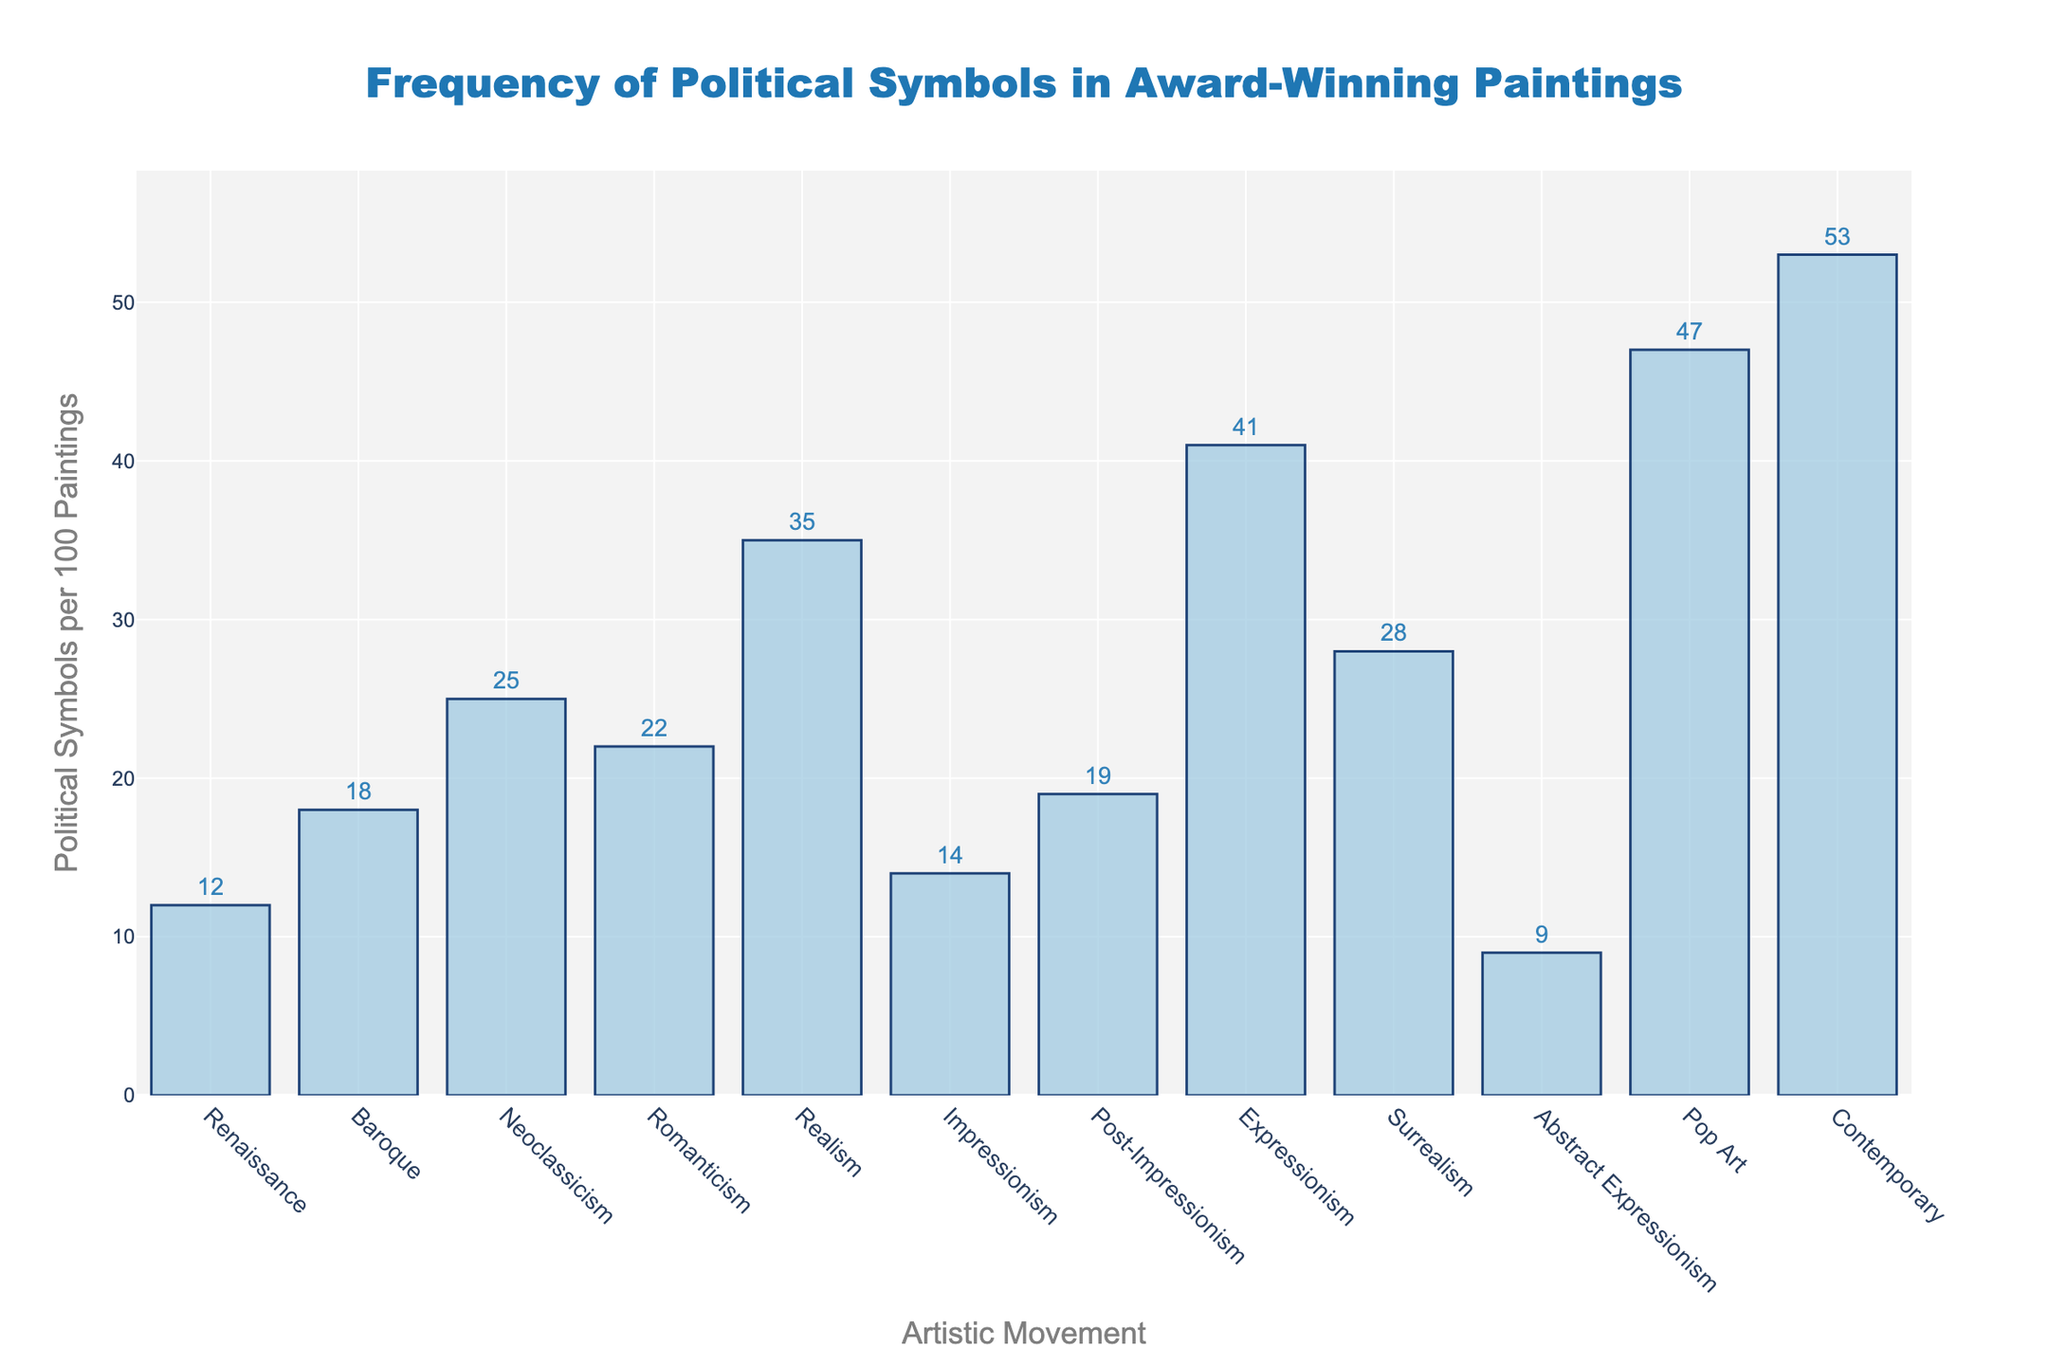What's the artistic movement with the highest frequency of political symbols? The tallest bar in the chart represents the "Contemporary" movement, indicating the highest frequency of political symbols per 100 paintings.
Answer: Contemporary Which artistic movement has a lower frequency of political symbols: Renaissance or Abstract Expressionism? By comparing the heights of the bars, "Abstract Expressionism" has fewer political symbols per 100 paintings (9) than the "Renaissance" (12).
Answer: Abstract Expressionism What is the difference in the frequency of political symbols between Surrealism and Realism? The bar for "Surrealism" shows 28 symbols, and "Realism" shows 35 symbols. The difference is 35 - 28 = 7 symbols.
Answer: 7 Which artistic movements have a frequency of political symbols greater than 20 but less than 30? Bars between 20 and 30 symbols represent "Romanticism" (22), "Post-Impressionism" (19), and "Surrealism" (28). After considering the given ranges, the applicable movements are "Romanticism" and "Surrealism".
Answer: Romanticism, Surrealism How many artistic movements have a frequency of political symbols less than 15? By evaluating the heights, the bars shorter than 15 symbols per 100 paintings are "Renaissance" (12), "Impressionism" (14), and "Abstract Expressionism" (9). Counting these, we get three movements.
Answer: 3 Which artistic movement shows a near 50% more frequency of political symbols compared to the Baroque period? Baroque has 18 symbols. 50% more would be 18 * 1.5 = 27. The movement closest to this value is "Surrealism" with 28 symbols.
Answer: Surrealism What is the average frequency of political symbols for Impressionism, Post-Impressionism, and Expressionism? Summing the values: 14 (Impressionism) + 19 (Post-Impressionism) + 41 (Expressionism) = 74. Dividing by the number of movements (3) gives an average of 24.67.
Answer: 24.67 How does the frequency of political symbols in Pop Art compare against the total frequency across all movements? Summing the frequencies: 12+18+25+22+35+14+19+41+28+9+47+53 = 323. Pop Art's share is (47 / 323) * 100 ≈ 14.55%.
Answer: 14.55% Which two successive artistic movements show the most significant increase in the frequency of political symbols? Identify the largest difference between consecutive movements: The largest increase is between "Realism" (35) and "Expressionism" (41) with a difference of 6 symbols.
Answer: Realism to Expressionism If the frequency of political symbols in Contemporary art decreased by 10%, what would the resulting value be? The original value for Contemporary is 53 symbols. Reducing by 10% yields 53 - (53 * 0.1) = 47.7 symbols.
Answer: 47.7 